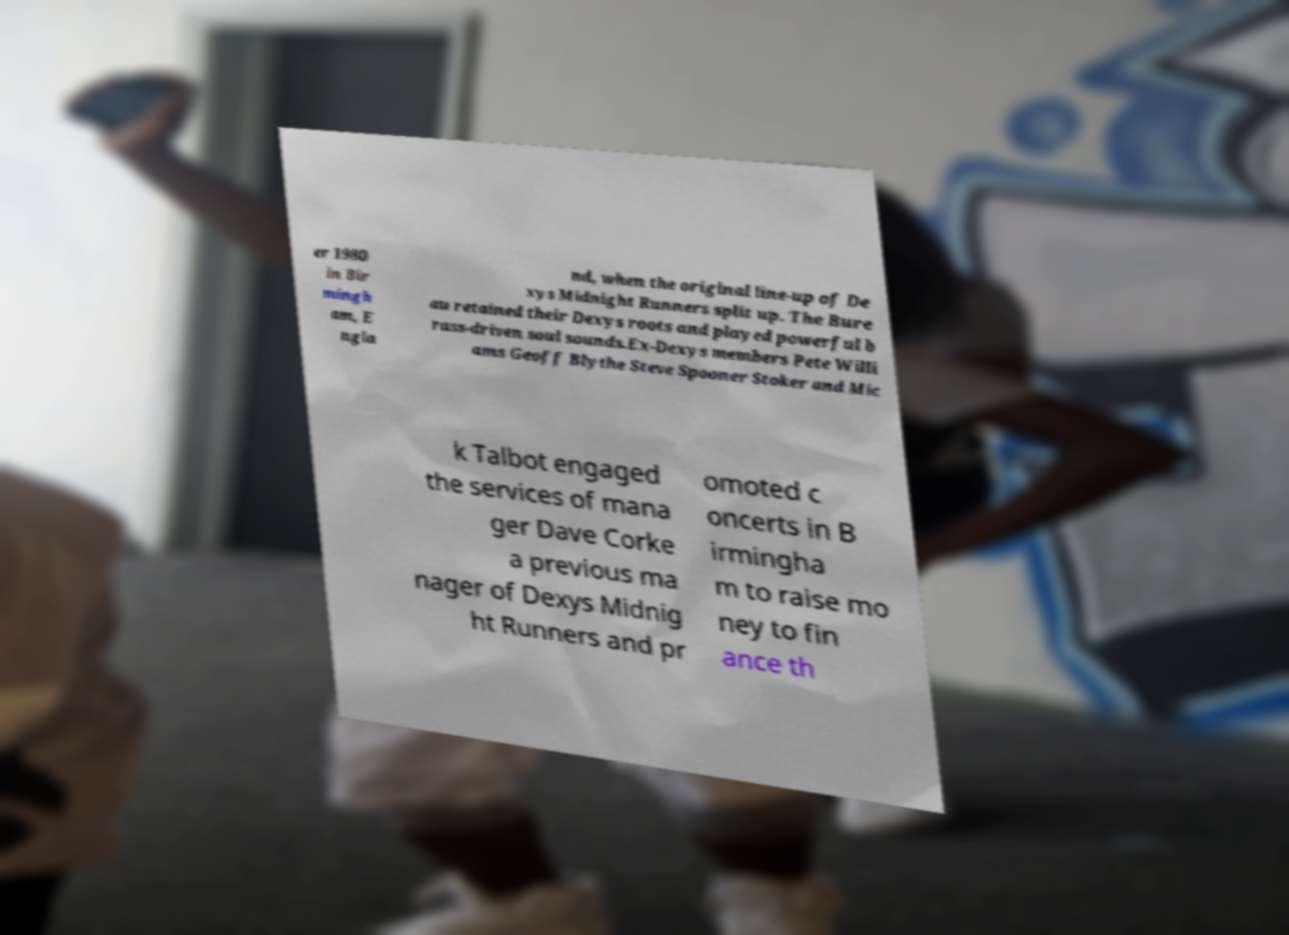Please identify and transcribe the text found in this image. er 1980 in Bir mingh am, E ngla nd, when the original line-up of De xys Midnight Runners split up. The Bure au retained their Dexys roots and played powerful b rass-driven soul sounds.Ex-Dexys members Pete Willi ams Geoff Blythe Steve Spooner Stoker and Mic k Talbot engaged the services of mana ger Dave Corke a previous ma nager of Dexys Midnig ht Runners and pr omoted c oncerts in B irmingha m to raise mo ney to fin ance th 